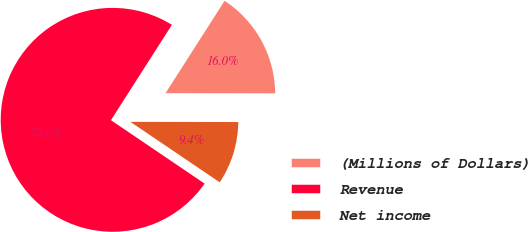<chart> <loc_0><loc_0><loc_500><loc_500><pie_chart><fcel>(Millions of Dollars)<fcel>Revenue<fcel>Net income<nl><fcel>15.97%<fcel>74.58%<fcel>9.45%<nl></chart> 